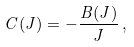<formula> <loc_0><loc_0><loc_500><loc_500>C ( J ) = - \frac { B ( J ) } { J } \, ,</formula> 